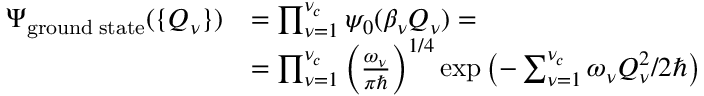<formula> <loc_0><loc_0><loc_500><loc_500>\begin{array} { r l } { \Psi _ { g r o u n d \, s t a t e } ( \{ Q _ { \nu } \} ) } & { = \prod _ { \nu = 1 } ^ { \nu _ { c } } \psi _ { 0 } ( \beta _ { \nu } Q _ { \nu } ) = } \\ & { = \prod _ { \nu = 1 } ^ { \nu _ { c } } \left ( \frac { \omega _ { \nu } } { \pi } \right ) ^ { 1 / 4 } \exp \left ( - \sum _ { \nu = 1 } ^ { \nu _ { c } } \omega _ { \nu } Q _ { \nu } ^ { 2 } / 2 \hbar { \right } ) } \end{array}</formula> 